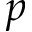Convert formula to latex. <formula><loc_0><loc_0><loc_500><loc_500>p</formula> 